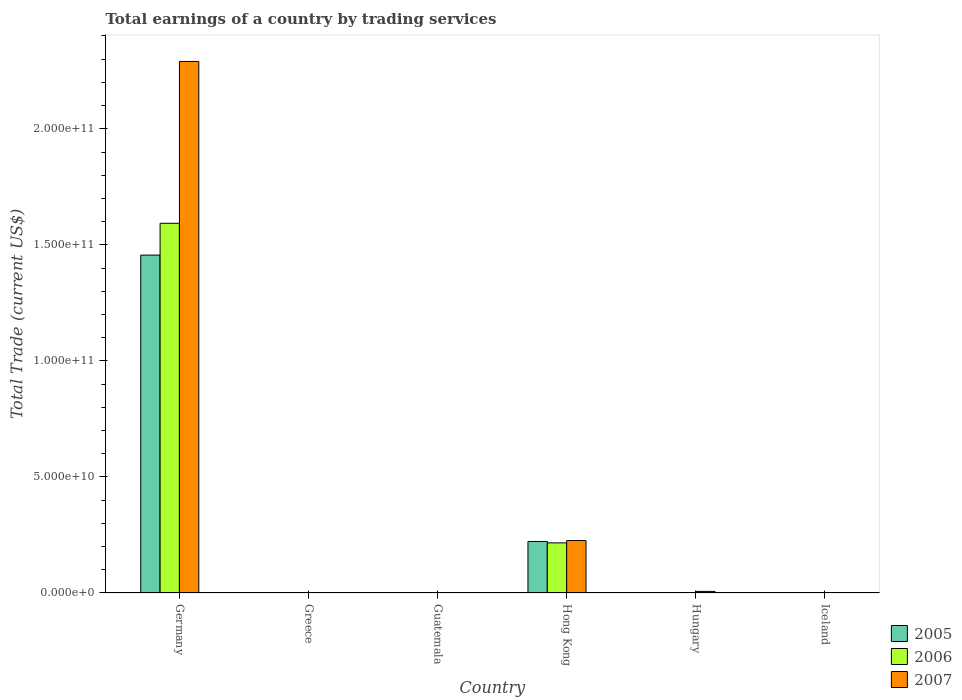How many different coloured bars are there?
Make the answer very short. 3. Are the number of bars per tick equal to the number of legend labels?
Your answer should be compact. No. How many bars are there on the 6th tick from the left?
Provide a succinct answer. 0. In how many cases, is the number of bars for a given country not equal to the number of legend labels?
Provide a short and direct response. 4. What is the total earnings in 2005 in Hong Kong?
Provide a succinct answer. 2.22e+1. Across all countries, what is the maximum total earnings in 2006?
Ensure brevity in your answer.  1.59e+11. Across all countries, what is the minimum total earnings in 2006?
Your answer should be compact. 0. What is the total total earnings in 2006 in the graph?
Your response must be concise. 1.81e+11. What is the difference between the total earnings in 2007 in Germany and that in Hungary?
Give a very brief answer. 2.28e+11. What is the difference between the total earnings in 2006 in Greece and the total earnings in 2007 in Hong Kong?
Provide a short and direct response. -2.26e+1. What is the average total earnings in 2006 per country?
Provide a succinct answer. 3.01e+1. What is the difference between the total earnings of/in 2005 and total earnings of/in 2007 in Hong Kong?
Make the answer very short. -4.01e+08. In how many countries, is the total earnings in 2005 greater than 40000000000 US$?
Your answer should be very brief. 1. What is the ratio of the total earnings in 2006 in Germany to that in Hong Kong?
Provide a short and direct response. 7.38. What is the difference between the highest and the second highest total earnings in 2007?
Your answer should be compact. 2.06e+11. What is the difference between the highest and the lowest total earnings in 2005?
Offer a terse response. 1.46e+11. In how many countries, is the total earnings in 2006 greater than the average total earnings in 2006 taken over all countries?
Keep it short and to the point. 1. How many bars are there?
Your answer should be compact. 7. Does the graph contain any zero values?
Give a very brief answer. Yes. Does the graph contain grids?
Give a very brief answer. No. Where does the legend appear in the graph?
Provide a short and direct response. Bottom right. How many legend labels are there?
Your answer should be very brief. 3. What is the title of the graph?
Your answer should be very brief. Total earnings of a country by trading services. Does "1963" appear as one of the legend labels in the graph?
Your response must be concise. No. What is the label or title of the Y-axis?
Keep it short and to the point. Total Trade (current US$). What is the Total Trade (current US$) in 2005 in Germany?
Make the answer very short. 1.46e+11. What is the Total Trade (current US$) of 2006 in Germany?
Your answer should be compact. 1.59e+11. What is the Total Trade (current US$) of 2007 in Germany?
Offer a very short reply. 2.29e+11. What is the Total Trade (current US$) of 2006 in Greece?
Offer a very short reply. 0. What is the Total Trade (current US$) in 2007 in Greece?
Your response must be concise. 0. What is the Total Trade (current US$) in 2006 in Guatemala?
Your answer should be compact. 0. What is the Total Trade (current US$) of 2007 in Guatemala?
Offer a terse response. 0. What is the Total Trade (current US$) in 2005 in Hong Kong?
Make the answer very short. 2.22e+1. What is the Total Trade (current US$) of 2006 in Hong Kong?
Provide a short and direct response. 2.16e+1. What is the Total Trade (current US$) of 2007 in Hong Kong?
Your answer should be very brief. 2.26e+1. What is the Total Trade (current US$) of 2005 in Hungary?
Make the answer very short. 0. What is the Total Trade (current US$) of 2006 in Hungary?
Your answer should be compact. 0. What is the Total Trade (current US$) in 2007 in Hungary?
Offer a terse response. 6.80e+08. What is the Total Trade (current US$) in 2005 in Iceland?
Offer a very short reply. 0. What is the Total Trade (current US$) of 2007 in Iceland?
Give a very brief answer. 0. Across all countries, what is the maximum Total Trade (current US$) in 2005?
Provide a short and direct response. 1.46e+11. Across all countries, what is the maximum Total Trade (current US$) in 2006?
Provide a short and direct response. 1.59e+11. Across all countries, what is the maximum Total Trade (current US$) of 2007?
Offer a very short reply. 2.29e+11. Across all countries, what is the minimum Total Trade (current US$) of 2005?
Your answer should be compact. 0. What is the total Total Trade (current US$) in 2005 in the graph?
Offer a terse response. 1.68e+11. What is the total Total Trade (current US$) of 2006 in the graph?
Keep it short and to the point. 1.81e+11. What is the total Total Trade (current US$) in 2007 in the graph?
Offer a terse response. 2.52e+11. What is the difference between the Total Trade (current US$) of 2005 in Germany and that in Hong Kong?
Ensure brevity in your answer.  1.23e+11. What is the difference between the Total Trade (current US$) in 2006 in Germany and that in Hong Kong?
Keep it short and to the point. 1.38e+11. What is the difference between the Total Trade (current US$) in 2007 in Germany and that in Hong Kong?
Offer a terse response. 2.06e+11. What is the difference between the Total Trade (current US$) of 2007 in Germany and that in Hungary?
Make the answer very short. 2.28e+11. What is the difference between the Total Trade (current US$) in 2007 in Hong Kong and that in Hungary?
Provide a short and direct response. 2.19e+1. What is the difference between the Total Trade (current US$) in 2005 in Germany and the Total Trade (current US$) in 2006 in Hong Kong?
Offer a terse response. 1.24e+11. What is the difference between the Total Trade (current US$) of 2005 in Germany and the Total Trade (current US$) of 2007 in Hong Kong?
Provide a succinct answer. 1.23e+11. What is the difference between the Total Trade (current US$) in 2006 in Germany and the Total Trade (current US$) in 2007 in Hong Kong?
Make the answer very short. 1.37e+11. What is the difference between the Total Trade (current US$) of 2005 in Germany and the Total Trade (current US$) of 2007 in Hungary?
Your answer should be very brief. 1.45e+11. What is the difference between the Total Trade (current US$) of 2006 in Germany and the Total Trade (current US$) of 2007 in Hungary?
Offer a terse response. 1.59e+11. What is the difference between the Total Trade (current US$) in 2005 in Hong Kong and the Total Trade (current US$) in 2007 in Hungary?
Provide a succinct answer. 2.15e+1. What is the difference between the Total Trade (current US$) of 2006 in Hong Kong and the Total Trade (current US$) of 2007 in Hungary?
Keep it short and to the point. 2.09e+1. What is the average Total Trade (current US$) of 2005 per country?
Your answer should be compact. 2.80e+1. What is the average Total Trade (current US$) in 2006 per country?
Offer a terse response. 3.01e+1. What is the average Total Trade (current US$) in 2007 per country?
Make the answer very short. 4.20e+1. What is the difference between the Total Trade (current US$) of 2005 and Total Trade (current US$) of 2006 in Germany?
Provide a succinct answer. -1.37e+1. What is the difference between the Total Trade (current US$) of 2005 and Total Trade (current US$) of 2007 in Germany?
Provide a short and direct response. -8.34e+1. What is the difference between the Total Trade (current US$) of 2006 and Total Trade (current US$) of 2007 in Germany?
Your response must be concise. -6.97e+1. What is the difference between the Total Trade (current US$) of 2005 and Total Trade (current US$) of 2006 in Hong Kong?
Offer a terse response. 6.01e+08. What is the difference between the Total Trade (current US$) in 2005 and Total Trade (current US$) in 2007 in Hong Kong?
Give a very brief answer. -4.01e+08. What is the difference between the Total Trade (current US$) of 2006 and Total Trade (current US$) of 2007 in Hong Kong?
Your response must be concise. -1.00e+09. What is the ratio of the Total Trade (current US$) in 2005 in Germany to that in Hong Kong?
Your answer should be compact. 6.56. What is the ratio of the Total Trade (current US$) in 2006 in Germany to that in Hong Kong?
Your answer should be compact. 7.38. What is the ratio of the Total Trade (current US$) of 2007 in Germany to that in Hong Kong?
Make the answer very short. 10.14. What is the ratio of the Total Trade (current US$) in 2007 in Germany to that in Hungary?
Give a very brief answer. 337.02. What is the ratio of the Total Trade (current US$) of 2007 in Hong Kong to that in Hungary?
Make the answer very short. 33.25. What is the difference between the highest and the second highest Total Trade (current US$) in 2007?
Keep it short and to the point. 2.06e+11. What is the difference between the highest and the lowest Total Trade (current US$) of 2005?
Your response must be concise. 1.46e+11. What is the difference between the highest and the lowest Total Trade (current US$) of 2006?
Provide a short and direct response. 1.59e+11. What is the difference between the highest and the lowest Total Trade (current US$) in 2007?
Offer a very short reply. 2.29e+11. 